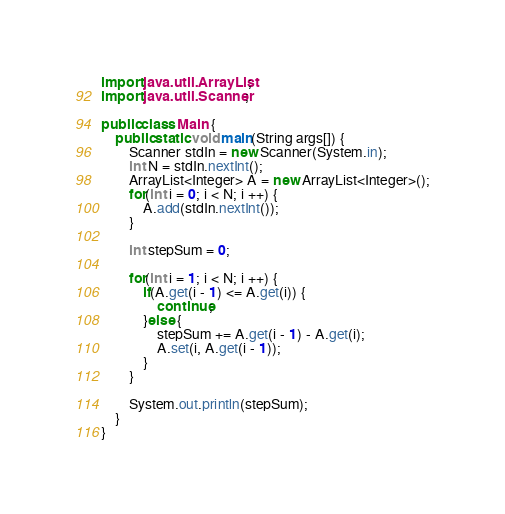Convert code to text. <code><loc_0><loc_0><loc_500><loc_500><_Java_>import java.util.ArrayList;
import java.util.Scanner;

public class Main {
	public static void main(String args[]) {
		Scanner stdIn = new Scanner(System.in);
		int N = stdIn.nextInt();
		ArrayList<Integer> A = new ArrayList<Integer>();
		for(int i = 0; i < N; i ++) {
			A.add(stdIn.nextInt());
		}
		
		int stepSum = 0;
		
		for(int i = 1; i < N; i ++) {
			if(A.get(i - 1) <= A.get(i)) {
				continue;
			}else {
				stepSum += A.get(i - 1) - A.get(i);
				A.set(i, A.get(i - 1));
			}
		}
		
		System.out.println(stepSum);
	}
}</code> 